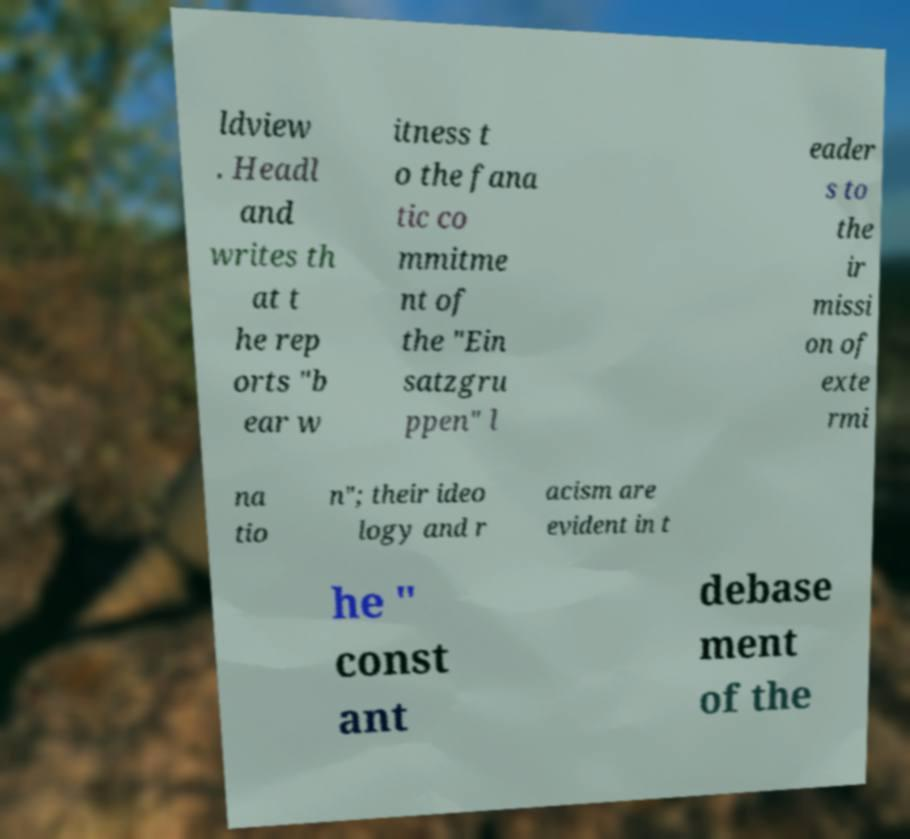For documentation purposes, I need the text within this image transcribed. Could you provide that? ldview . Headl and writes th at t he rep orts "b ear w itness t o the fana tic co mmitme nt of the "Ein satzgru ppen" l eader s to the ir missi on of exte rmi na tio n"; their ideo logy and r acism are evident in t he " const ant debase ment of the 